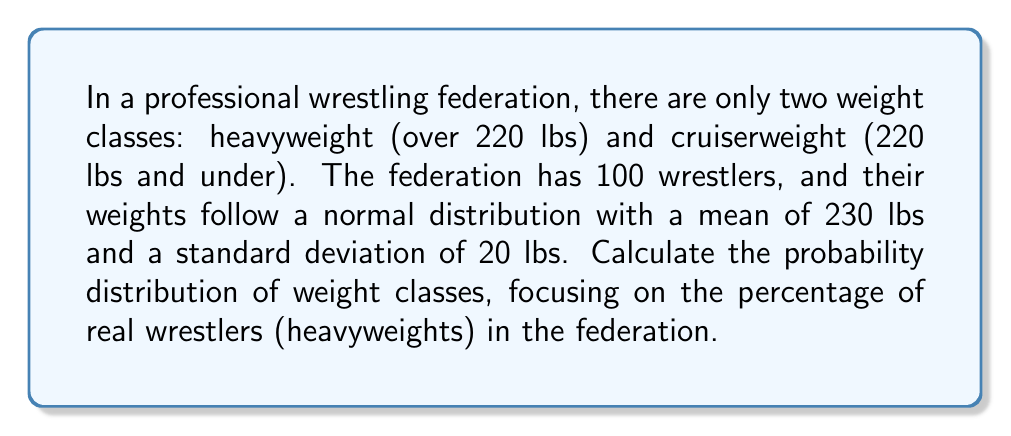Can you answer this question? To solve this problem, we need to follow these steps:

1. Identify the relevant probability distribution:
   The weights follow a normal distribution with μ = 230 lbs and σ = 20 lbs.

2. Determine the cutoff point between weight classes:
   Heavyweight: > 220 lbs
   Cruiserweight: ≤ 220 lbs

3. Calculate the z-score for the cutoff point:
   $$z = \frac{x - \mu}{\sigma} = \frac{220 - 230}{20} = -0.5$$

4. Use the standard normal distribution table or a calculator to find the probability of a wrestler being a cruiserweight:
   $$P(X \leq 220) = P(Z \leq -0.5) \approx 0.3085$$

5. Calculate the probability of a wrestler being a heavyweight:
   $$P(X > 220) = 1 - P(X \leq 220) = 1 - 0.3085 = 0.6915$$

6. Convert the probability to a percentage:
   Percentage of heavyweights = 0.6915 × 100% = 69.15%

The probability distribution of weight classes is:
Heavyweight: 69.15%
Cruiserweight: 30.85%
Answer: 69.15% heavyweights, 30.85% cruiserweights 